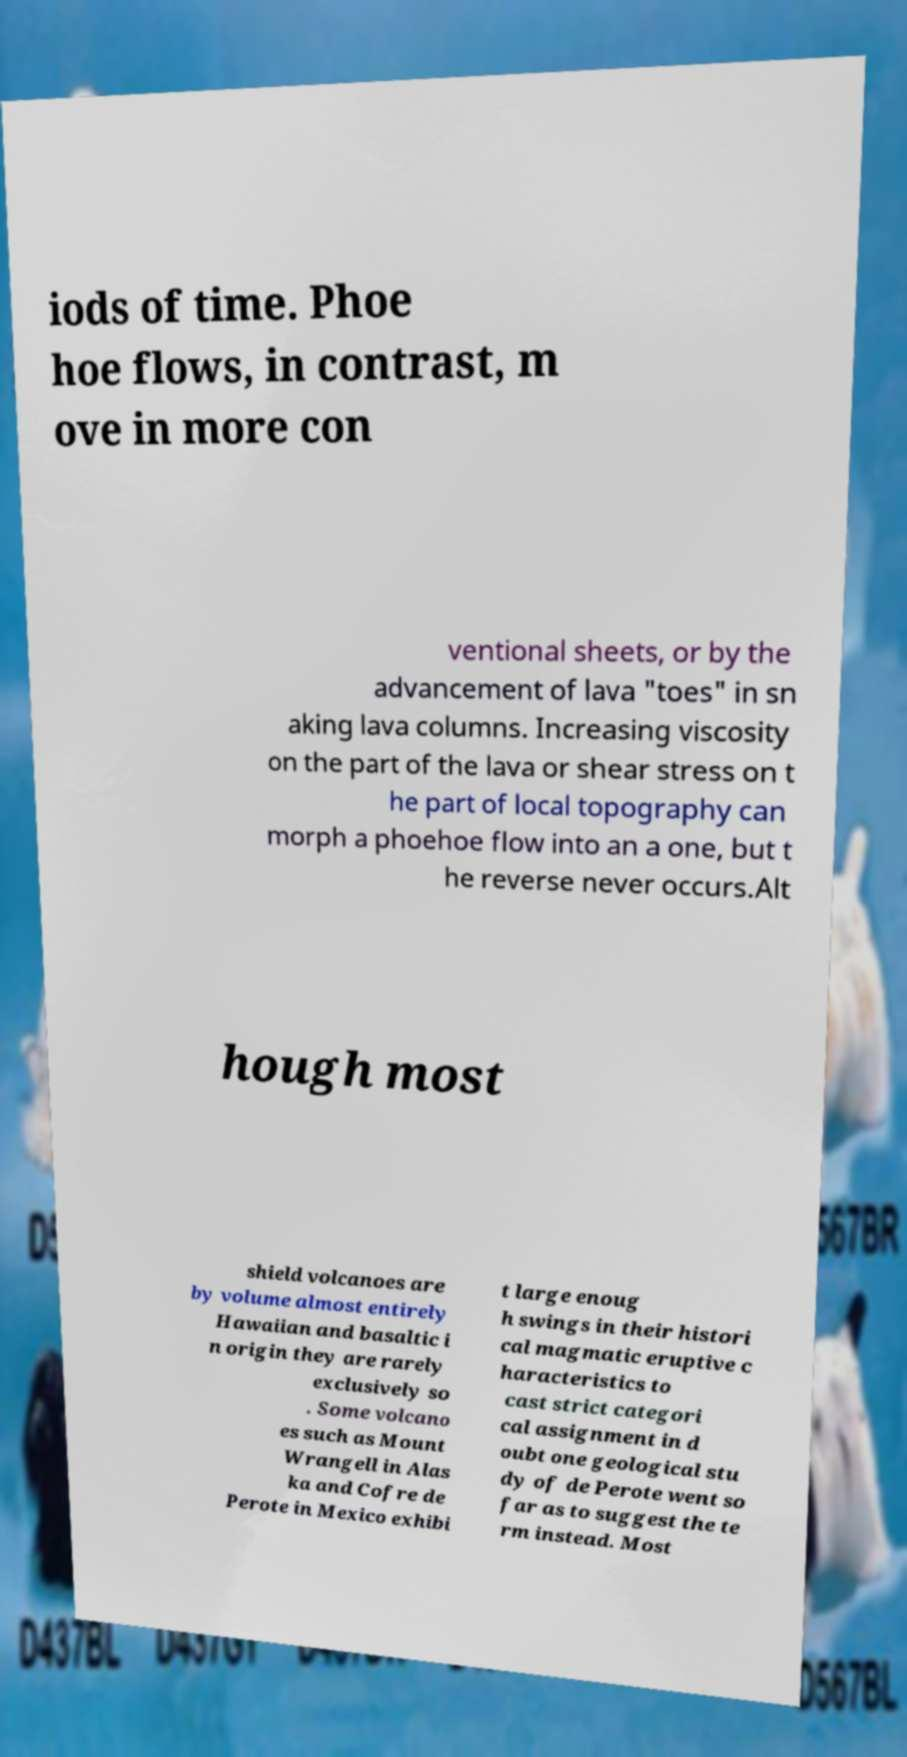What messages or text are displayed in this image? I need them in a readable, typed format. iods of time. Phoe hoe flows, in contrast, m ove in more con ventional sheets, or by the advancement of lava "toes" in sn aking lava columns. Increasing viscosity on the part of the lava or shear stress on t he part of local topography can morph a phoehoe flow into an a one, but t he reverse never occurs.Alt hough most shield volcanoes are by volume almost entirely Hawaiian and basaltic i n origin they are rarely exclusively so . Some volcano es such as Mount Wrangell in Alas ka and Cofre de Perote in Mexico exhibi t large enoug h swings in their histori cal magmatic eruptive c haracteristics to cast strict categori cal assignment in d oubt one geological stu dy of de Perote went so far as to suggest the te rm instead. Most 